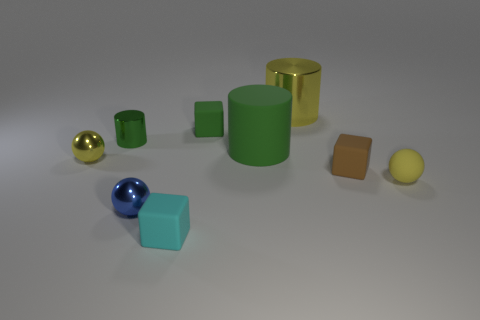Subtract all green cylinders. How many cylinders are left? 1 Subtract all purple spheres. How many green cylinders are left? 2 Subtract 1 cylinders. How many cylinders are left? 2 Subtract all cylinders. How many objects are left? 6 Add 6 tiny blue spheres. How many tiny blue spheres are left? 7 Add 3 yellow rubber objects. How many yellow rubber objects exist? 4 Subtract 0 red cylinders. How many objects are left? 9 Subtract all green balls. Subtract all yellow cylinders. How many balls are left? 3 Subtract all tiny matte spheres. Subtract all metal spheres. How many objects are left? 6 